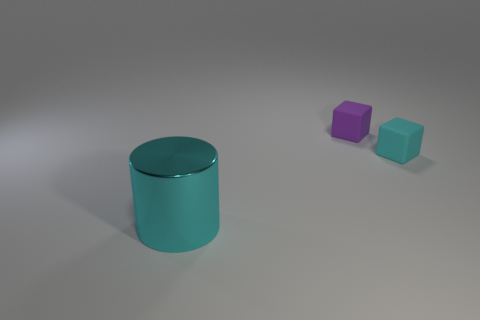What kind of setting does this image suggest? The image presents a sparse and neutral setting with a gentle gradient in the background hinting at a light source to the upper left. There is little context provided, which could imply a focus on the objects themselves for either illustrative purposes or as objects of interest within a minimalist environment. This kind of setting is common in product showcases or when emphasizing the design aspects of the objects. 